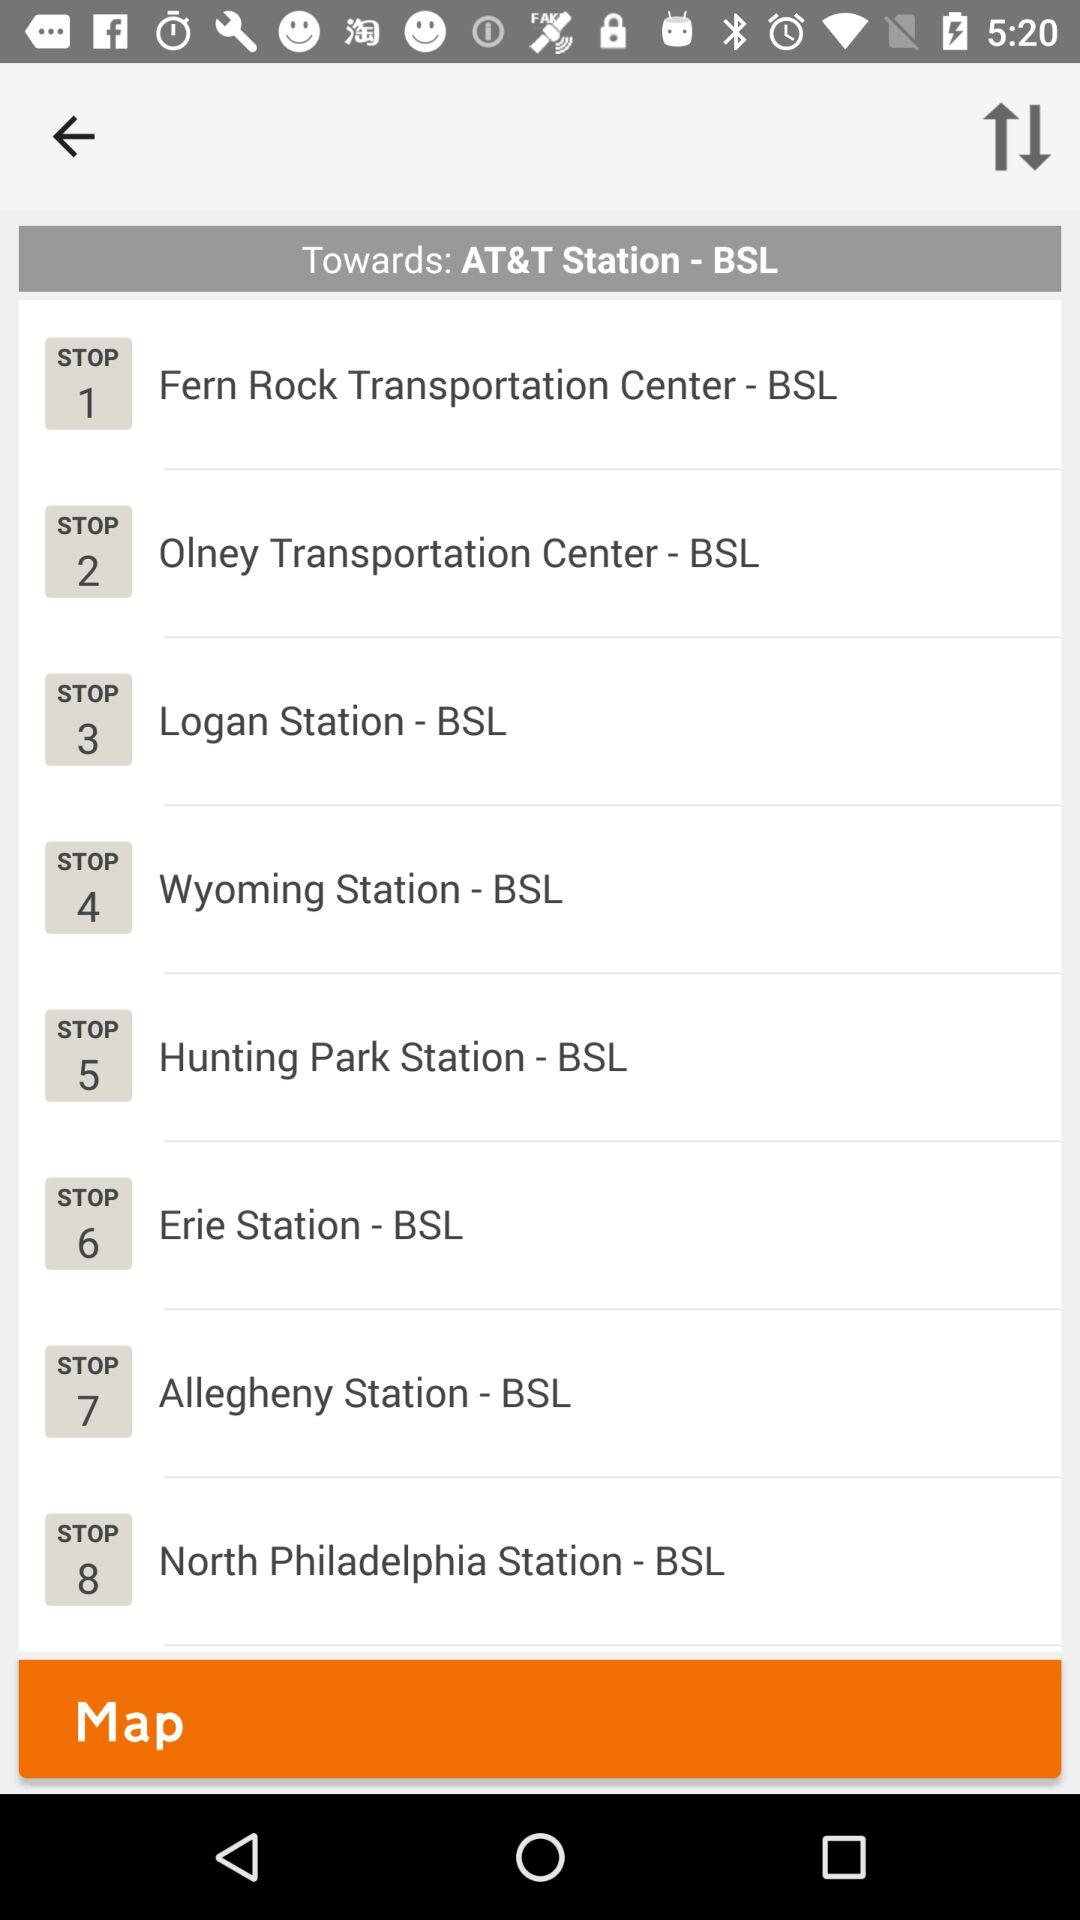What is the seventh stop? It is "Allegheny Station - BSL". 